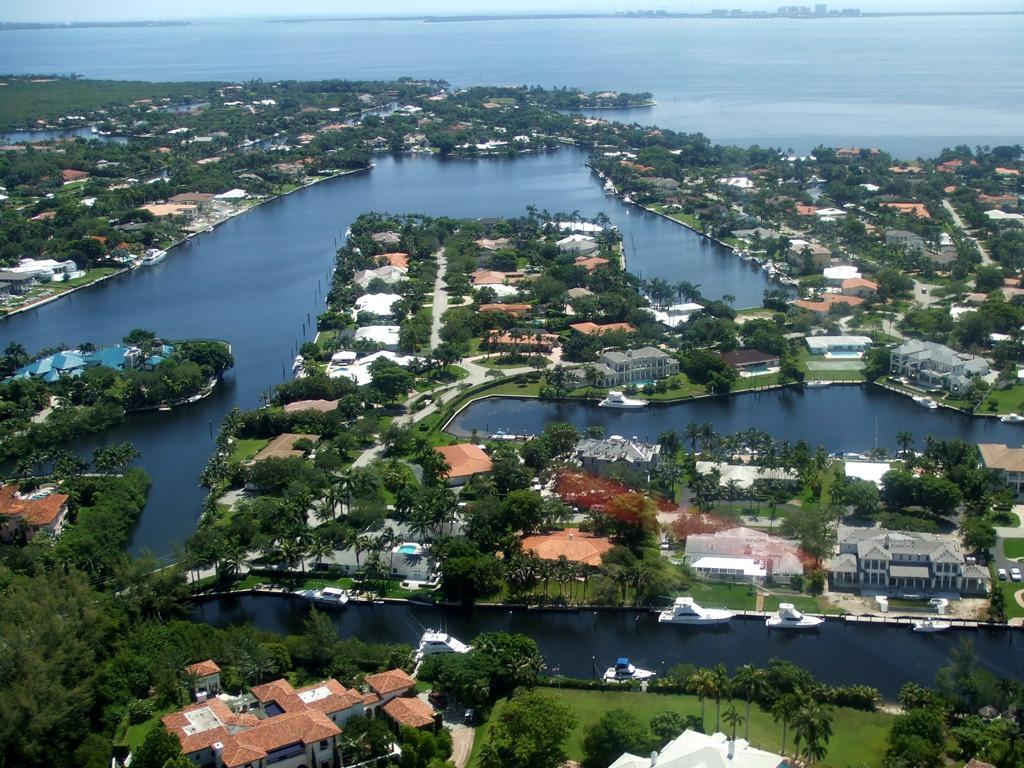Can you describe this image briefly? In this image we can see an ocean, buildings, trees, street poles and ground. 